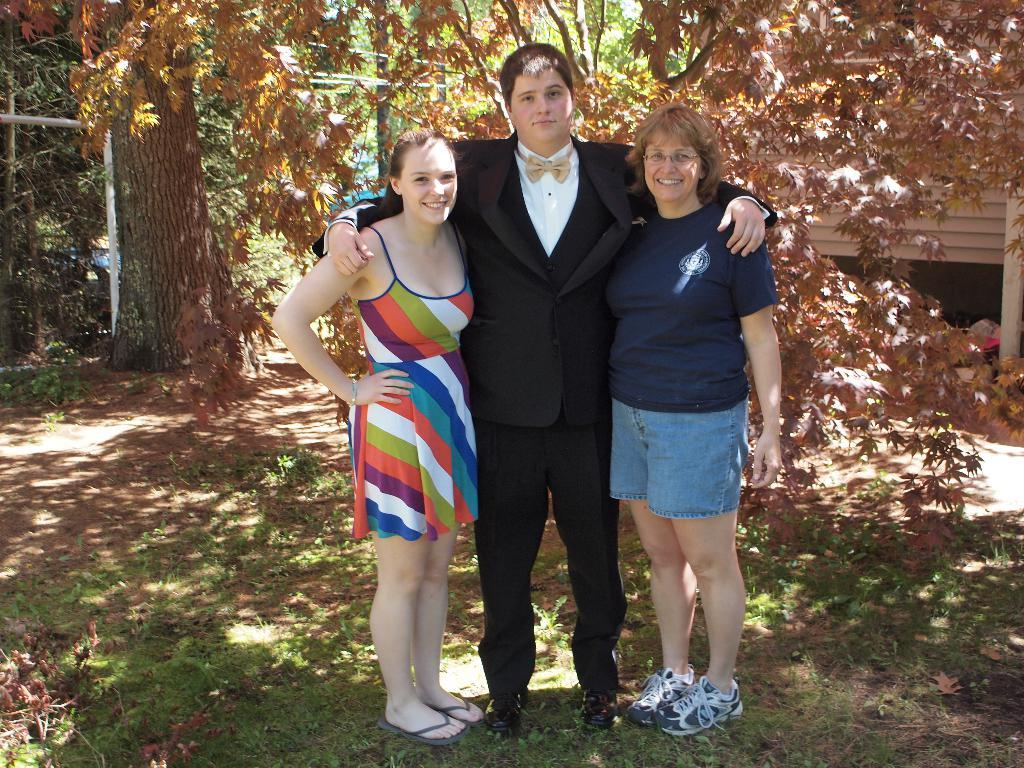How many people are in the image? There are three people in the center of the image. What is the surface at the bottom of the image made of? There is grass on the surface at the bottom of the image. What can be seen in the background of the image? There are trees and a building in the background of the image. What type of fiction is the glove reading in the image? There is no glove or fiction present in the image. How many trains are visible in the image? There are no trains visible in the image. 